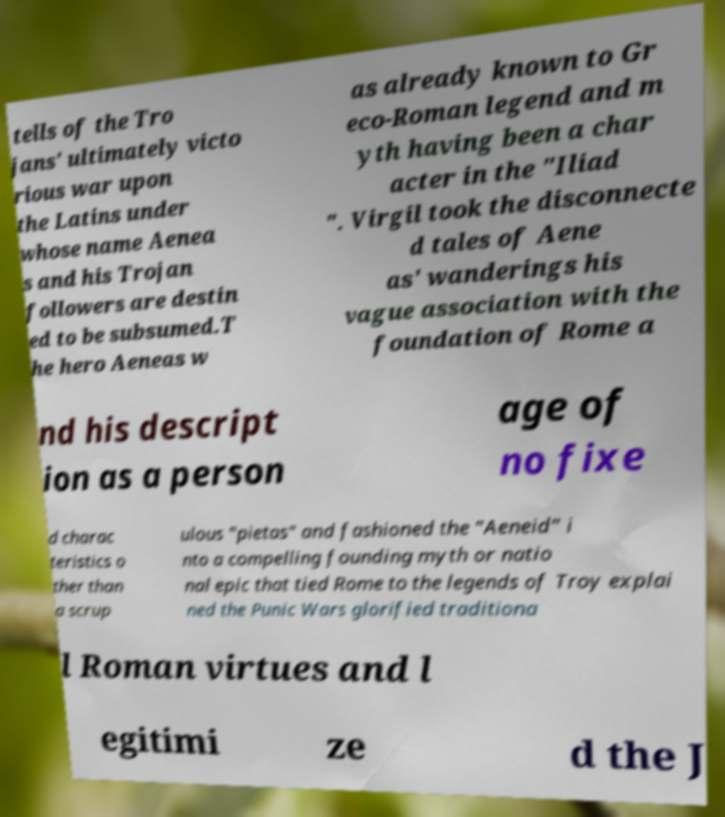I need the written content from this picture converted into text. Can you do that? tells of the Tro jans' ultimately victo rious war upon the Latins under whose name Aenea s and his Trojan followers are destin ed to be subsumed.T he hero Aeneas w as already known to Gr eco-Roman legend and m yth having been a char acter in the "Iliad ". Virgil took the disconnecte d tales of Aene as' wanderings his vague association with the foundation of Rome a nd his descript ion as a person age of no fixe d charac teristics o ther than a scrup ulous "pietas" and fashioned the "Aeneid" i nto a compelling founding myth or natio nal epic that tied Rome to the legends of Troy explai ned the Punic Wars glorified traditiona l Roman virtues and l egitimi ze d the J 